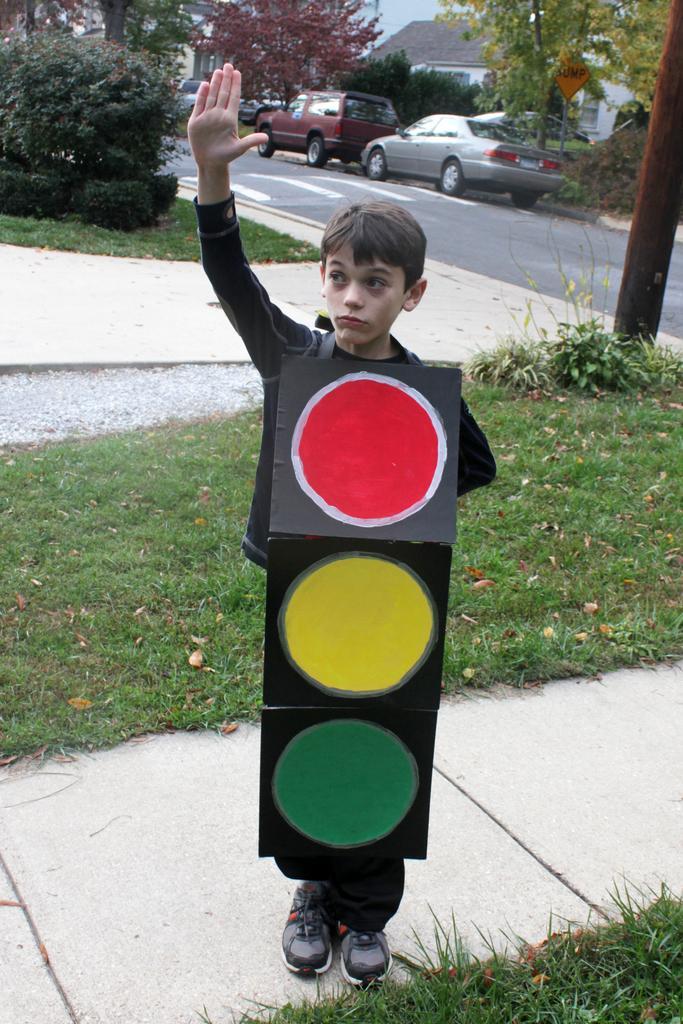Describe this image in one or two sentences. In the middle of the image a boy is standing and holding a sign board. Behind him we can see grass, plants and poles. At the top of the image we can see some vehicles on the road. Behind the vehicles we can see some trees and buildings. 